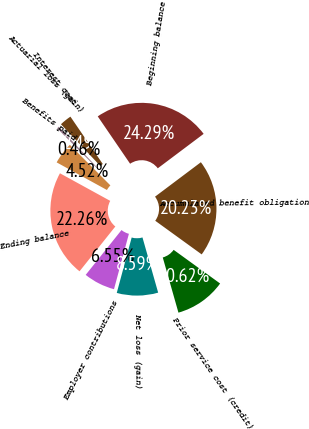<chart> <loc_0><loc_0><loc_500><loc_500><pie_chart><fcel>Accumulated benefit obligation<fcel>Beginning balance<fcel>Interest cost<fcel>Actuarial loss (gain)<fcel>Benefits paid<fcel>Ending balance<fcel>Employer contributions<fcel>Net loss (gain)<fcel>Prior service cost (credit)<nl><fcel>20.23%<fcel>24.29%<fcel>2.49%<fcel>0.46%<fcel>4.52%<fcel>22.26%<fcel>6.55%<fcel>8.59%<fcel>10.62%<nl></chart> 